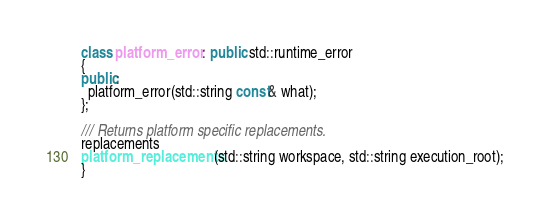<code> <loc_0><loc_0><loc_500><loc_500><_C++_>class platform_error : public std::runtime_error
{
public:
  platform_error(std::string const& what);
};

/// Returns platform specific replacements.
replacements
platform_replacements(std::string workspace, std::string execution_root);
}
</code> 